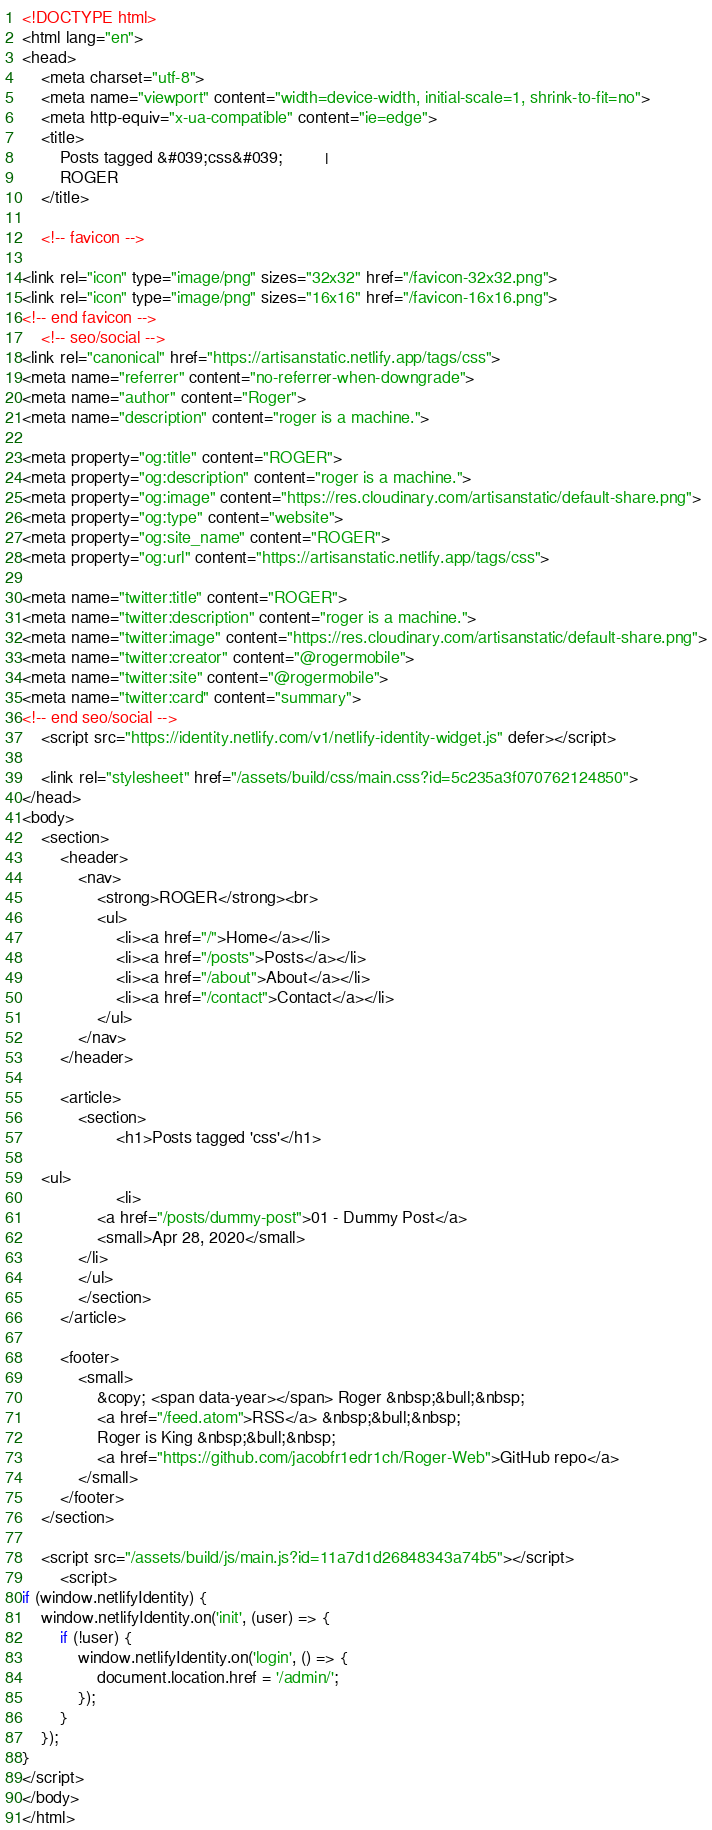<code> <loc_0><loc_0><loc_500><loc_500><_HTML_><!DOCTYPE html>
<html lang="en">
<head>
    <meta charset="utf-8">
    <meta name="viewport" content="width=device-width, initial-scale=1, shrink-to-fit=no">
    <meta http-equiv="x-ua-compatible" content="ie=edge">
    <title>
        Posts tagged &#039;css&#039;         | 
        ROGER
    </title>

    <!-- favicon -->

<link rel="icon" type="image/png" sizes="32x32" href="/favicon-32x32.png">
<link rel="icon" type="image/png" sizes="16x16" href="/favicon-16x16.png">
<!-- end favicon -->
    <!-- seo/social -->
<link rel="canonical" href="https://artisanstatic.netlify.app/tags/css">
<meta name="referrer" content="no-referrer-when-downgrade">
<meta name="author" content="Roger">
<meta name="description" content="roger is a machine.">

<meta property="og:title" content="ROGER">
<meta property="og:description" content="roger is a machine.">
<meta property="og:image" content="https://res.cloudinary.com/artisanstatic/default-share.png">
<meta property="og:type" content="website">
<meta property="og:site_name" content="ROGER">
<meta property="og:url" content="https://artisanstatic.netlify.app/tags/css">

<meta name="twitter:title" content="ROGER">
<meta name="twitter:description" content="roger is a machine.">
<meta name="twitter:image" content="https://res.cloudinary.com/artisanstatic/default-share.png">
<meta name="twitter:creator" content="@rogermobile">
<meta name="twitter:site" content="@rogermobile">
<meta name="twitter:card" content="summary">
<!-- end seo/social -->
    <script src="https://identity.netlify.com/v1/netlify-identity-widget.js" defer></script>

    <link rel="stylesheet" href="/assets/build/css/main.css?id=5c235a3f070762124850">
</head>
<body>
    <section>
        <header>
            <nav>
                <strong>ROGER</strong><br>
                <ul>
                    <li><a href="/">Home</a></li>
                    <li><a href="/posts">Posts</a></li>
                    <li><a href="/about">About</a></li>
                    <li><a href="/contact">Contact</a></li>
                </ul>
            </nav>
        </header>

        <article>
            <section>
                    <h1>Posts tagged 'css'</h1>

    <ul>
                    <li>
                <a href="/posts/dummy-post">01 - Dummy Post</a>
                <small>Apr 28, 2020</small>
            </li>
            </ul>
            </section>
        </article>

        <footer>
            <small>
                &copy; <span data-year></span> Roger &nbsp;&bull;&nbsp;
                <a href="/feed.atom">RSS</a> &nbsp;&bull;&nbsp;
                Roger is King &nbsp;&bull;&nbsp;
                <a href="https://github.com/jacobfr1edr1ch/Roger-Web">GitHub repo</a>
            </small>
        </footer>
    </section>

    <script src="/assets/build/js/main.js?id=11a7d1d26848343a74b5"></script>
        <script>
if (window.netlifyIdentity) {
    window.netlifyIdentity.on('init', (user) => {
        if (!user) {
            window.netlifyIdentity.on('login', () => {
                document.location.href = '/admin/';
            });
        }
    });
}
</script>
</body>
</html>
</code> 